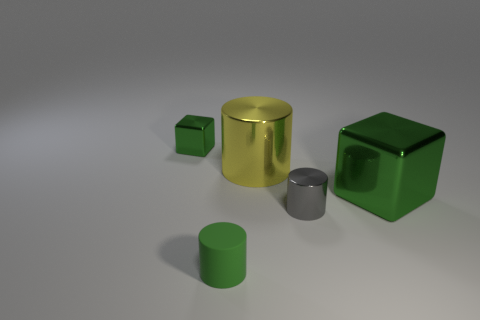Add 2 yellow cubes. How many objects exist? 7 Subtract all cubes. How many objects are left? 3 Subtract 0 brown cylinders. How many objects are left? 5 Subtract all rubber cylinders. Subtract all green cylinders. How many objects are left? 3 Add 2 large shiny cylinders. How many large shiny cylinders are left? 3 Add 5 big shiny cubes. How many big shiny cubes exist? 6 